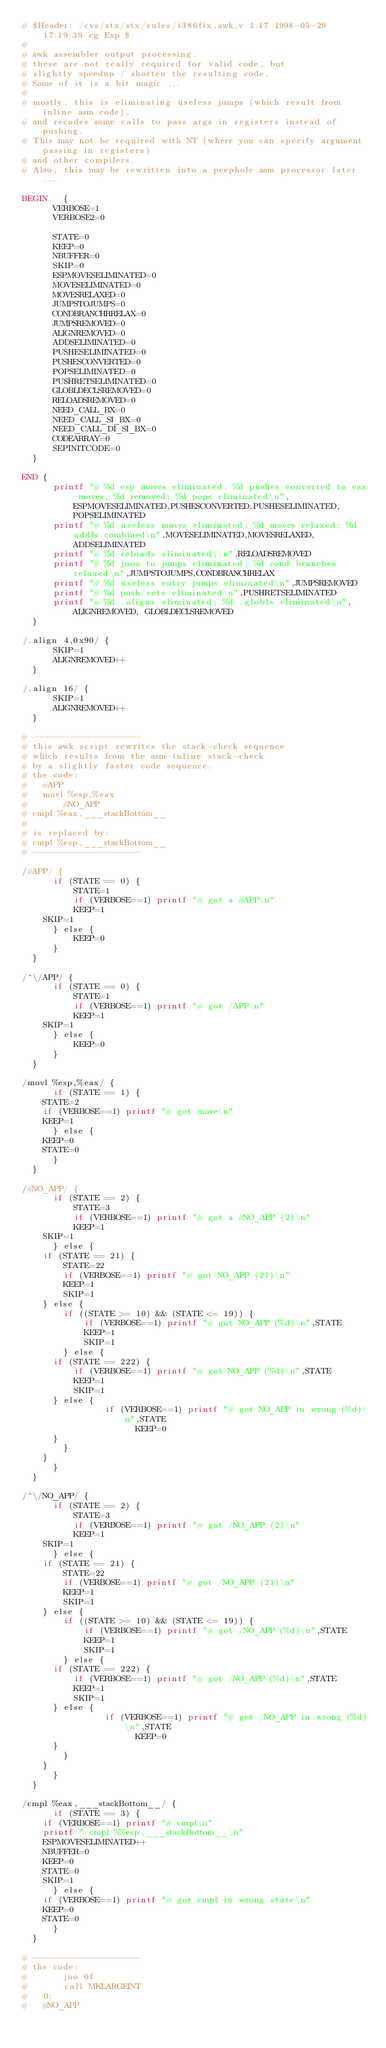Convert code to text. <code><loc_0><loc_0><loc_500><loc_500><_Awk_># $Header: /cvs/stx/stx/rules/i386fix.awk,v 1.17 1998-05-29 17:19:39 cg Exp $
#
# awk assembler output processing.
# these are not really required for valid code, but
# slightly speedup / shorten the resulting code.
# Some of it is a bit magic ...
#
# mostly, this is eliminating useless jumps (which result from inline asm code),
# and recodes some calls to pass args in registers instead of pushing.
# This may not be required with NT (where you can specify argument passing in registers)
# and other compilers.
# Also, this may be rewritten into a peephole asm processor later ...

BEGIN   {
	    VERBOSE=1
	    VERBOSE2=0

	    STATE=0
	    KEEP=0
	    NBUFFER=0
	    SKIP=0
	    ESPMOVESELIMINATED=0
	    MOVESELIMINATED=0
	    MOVESRELAXED=0
	    JUMPSTOJUMPS=0
	    CONDBRANCHRRELAX=0
	    JUMPSREMOVED=0
	    ALIGNREMOVED=0
	    ADDSELIMINATED=0
	    PUSHESELIMINATED=0
	    PUSHESCONVERTED=0
	    POPSELIMINATED=0
	    PUSHRETSELIMINATED=0
	    GLOBLDECLSREMOVED=0
	    RELOADSREMOVED=0
	    NEED_CALL_BX=0
	    NEED_CALL_SI_BX=0
	    NEED_CALL_DI_SI_BX=0
	    CODEARRAY=0
	    SEPINITCODE=0
	}

END	{
	    printf "# %d esp moves eliminated; %d pushes converted to eax-moves, %d removed; %d pops eliminated\n",ESPMOVESELIMINATED,PUSHESCONVERTED,PUSHESELIMINATED,POPSELIMINATED
	    printf "# %d useless moves eliminated; %d moves relaxed; %d addls combined\n",MOVESELIMINATED,MOVESRELAXED,ADDSELIMINATED
	    printf "# %d reloads eliminated;\n",RELOADSREMOVED
	    printf "# %d jnos to jumps eliminated; %d cond branches relaxed\n",JUMPSTOJUMPS,CONDBRANCHRELAX
	    printf "# %d useless entry jumps eliminated\n",JUMPSREMOVED
	    printf "# %d push/rets eliminated\n",PUSHRETSELIMINATED
	    printf "# %d .aligns eliminated; %d .globls eliminated\n",ALIGNREMOVED, GLOBLDECLSREMOVED
	}

/.align 4,0x90/ {
	    SKIP=1
	    ALIGNREMOVED++
	}

/.align 16/ {
	    SKIP=1
	    ALIGNREMOVED++
	}

# ---------------------
# this awk script rewrites the stack-check sequence
# which results from the asm-inline stack-check
# by a slightly faster code sequence.
# the code:
# 	#APP
#  	movl %esp,%eax
#       #NO_APP
#	cmpl %eax,___stackBottom__
#
# is replaced by:
#	cmpl %esp,___stackBottom__
# ---------------------

/#APP/ {
	    if (STATE == 0) {
	        STATE=1
	        if (VERBOSE==1) printf "# got a #APP\n"
	        KEEP=1
		SKIP=1
	    } else {
	        KEEP=0
	    }
	}

/^\/APP/ {
	    if (STATE == 0) {
	        STATE=1
	        if (VERBOSE==1) printf "# got /APP\n"
	        KEEP=1
		SKIP=1
	    } else {
	        KEEP=0
	    }
	}

/movl %esp,%eax/ {
	    if (STATE == 1) {
		STATE=2
		if (VERBOSE==1) printf "# got move\n"
		KEEP=1
	    } else {
		KEEP=0
		STATE=0
	    }
	}

/#NO_APP/ {
	    if (STATE == 2) {
	        STATE=3
	        if (VERBOSE==1) printf "# got a #NO_APP (2)\n"
	        KEEP=1
		SKIP=1
	    } else {
		if (STATE == 21) {
		    STATE=22
		    if (VERBOSE==1) printf "# got NO_APP (21)\n"
		    KEEP=1
		    SKIP=1
		} else {
		    if ((STATE >= 10) && (STATE <= 19)) {
		        if (VERBOSE==1) printf "# got NO_APP (%d)\n",STATE
		        KEEP=1
		        SKIP=1
		    } else {
			if (STATE == 222) {
			    if (VERBOSE==1) printf "# got NO_APP (%d)\n",STATE
			    KEEP=1
			    SKIP=1
			} else {
		            if (VERBOSE==1) printf "# got NO_APP in wrong (%d)\n",STATE
	                    KEEP=0
			}
		    }
		}
	    }
	}

/^\/NO_APP/ {
	    if (STATE == 2) {
	        STATE=3
	        if (VERBOSE==1) printf "# got /NO_APP (2)\n"
	        KEEP=1
		SKIP=1
	    } else {
		if (STATE == 21) {
		    STATE=22
		    if (VERBOSE==1) printf "# got /NO_APP (21)\n"
		    KEEP=1
		    SKIP=1
		} else {
		    if ((STATE >= 10) && (STATE <= 19)) {
		        if (VERBOSE==1) printf "# got /NO_APP (%d)\n",STATE
		        KEEP=1
		        SKIP=1
		    } else {
			if (STATE == 222) {
			    if (VERBOSE==1) printf "# got /NO_APP (%d)\n",STATE
			    KEEP=1
			    SKIP=1
			} else {
		            if (VERBOSE==1) printf "# got /NO_APP in wrong (%d)\n",STATE
	                    KEEP=0
			}
		    }
		}
	    }
	}

/cmpl %eax,___stackBottom__/ {
	    if (STATE == 3) {
		if (VERBOSE==1) printf "# cmpl\n"
		printf " cmpl %%esp,___stackBottom__\n"
		ESPMOVESELIMINATED++
		NBUFFER=0
		KEEP=0
		STATE=0
		SKIP=1
	    } else {
		if (VERBOSE==1) printf "# got cmpl in wrong state\n"
		KEEP=0
		STATE=0
	    }
	}

# ---------------------
# the code:
#       jno 0f
#       call MKLARGEINT
#   0:
#   #NO_APP</code> 